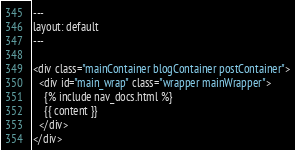Convert code to text. <code><loc_0><loc_0><loc_500><loc_500><_HTML_>---
layout: default
---

<div class="mainContainer blogContainer postContainer">
  <div id="main_wrap" class="wrapper mainWrapper">
    {% include nav_docs.html %}
    {{ content }}
  </div>
</div>

</code> 